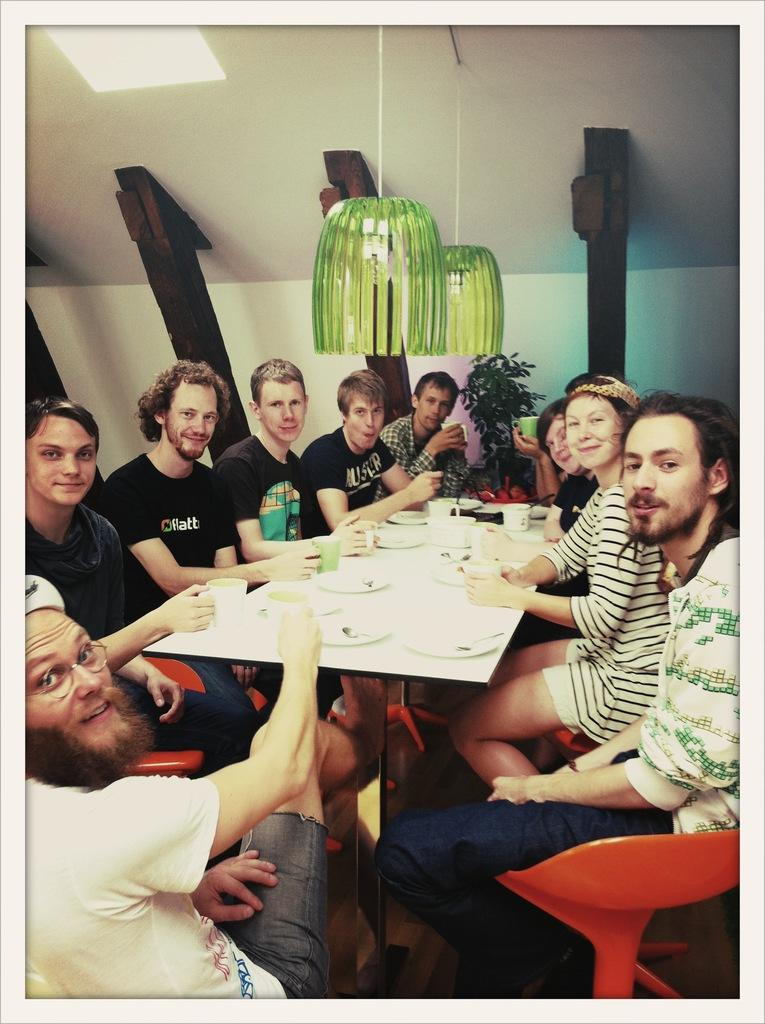What are the people in the image doing? The people in the image are sitting on chairs. Can you describe the expressions of the people in the image? Some people in the image have smiles on their faces. What objects can be seen on the table in the image? There are plates and mugs on the table in the image. What can be seen in the background of the image? There is a plant visible in the background of the image. What type of army is marching through the room in the image? There is no army present in the image; it features people sitting on chairs, plates and mugs on a table, and a plant in the background. What kind of clouds can be seen through the window in the image? There is no window or clouds visible in the image. 